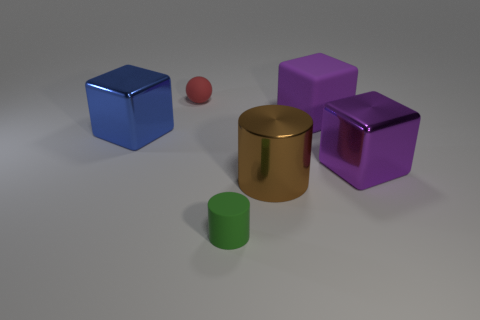There is another object that is the same size as the red rubber object; what color is it? green 